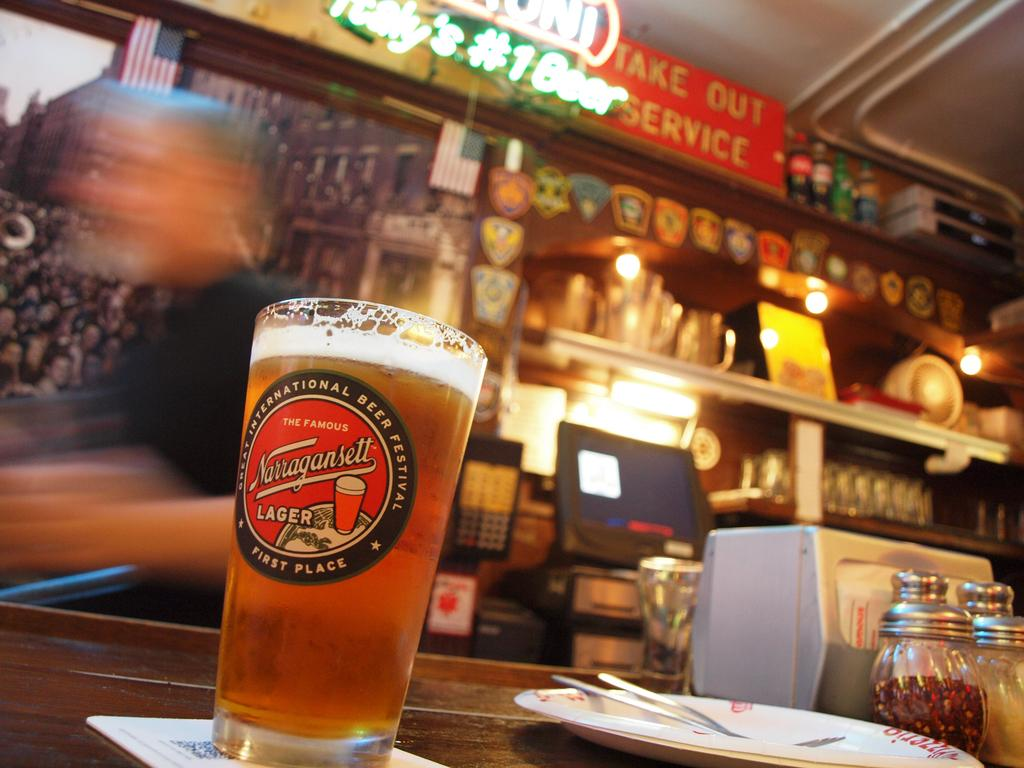<image>
Offer a succinct explanation of the picture presented. a glass of lager is on the bar where they offer take out 